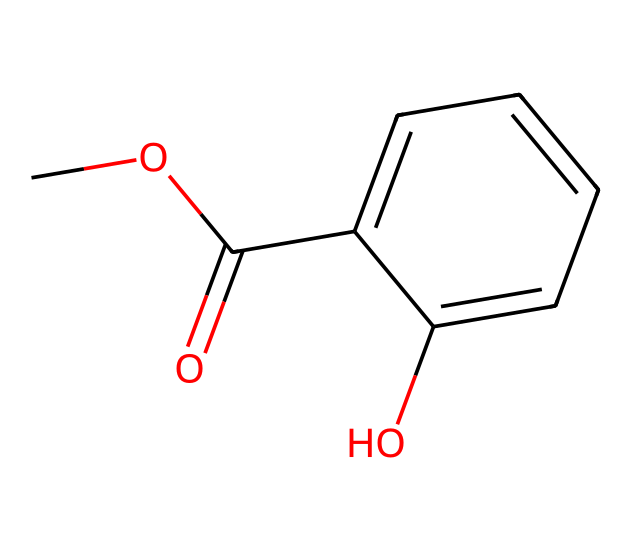What is the molecular formula of methyl salicylate? To determine the molecular formula, we count the number of each type of atom in the SMILES representation. The structure contains 10 carbon (C) atoms, 12 hydrogen (H) atoms, and 3 oxygen (O) atoms, resulting in the formula C9H10O3.
Answer: C9H10O3 How many rings are present in the structure? By analyzing the chemical structure, we look for cyclic components. The structure includes one aromatic ring denoted by the 'C1' in the SMILES, indicating a single ring.
Answer: 1 What type of functional groups are found in methyl salicylate? In the SMILES representation, we identify functional groups such as the ester (COC(=O)) and hydroxyl (–OH) groups from the –C1=CC=CC=C1O part. Both groups are essential for the properties of this compound.
Answer: ester and hydroxyl What is the significance of the hydroxyl group in this ester? The presence of the hydroxyl group contributes to the compound's ability to donate hydrogen ions, affecting its solubility and reactivity. Moreover, this group contributes to the scent associated with methyl salicylate.
Answer: scent and solubility What would be the expected state of methyl salicylate at room temperature? Given that methyl salicylate is an ester with a relatively low molecular weight and has a pleasant odor, it is typically expected to be a liquid at room temperature due to its volatility and low boiling point.
Answer: liquid What role does the aromatic ring play in the properties of methyl salicylate? The aromatic ring provides stability and distinct aromatic properties, contributing significantly to the compound's fragrance, which is why it is used in car air fresheners.
Answer: fragrance 